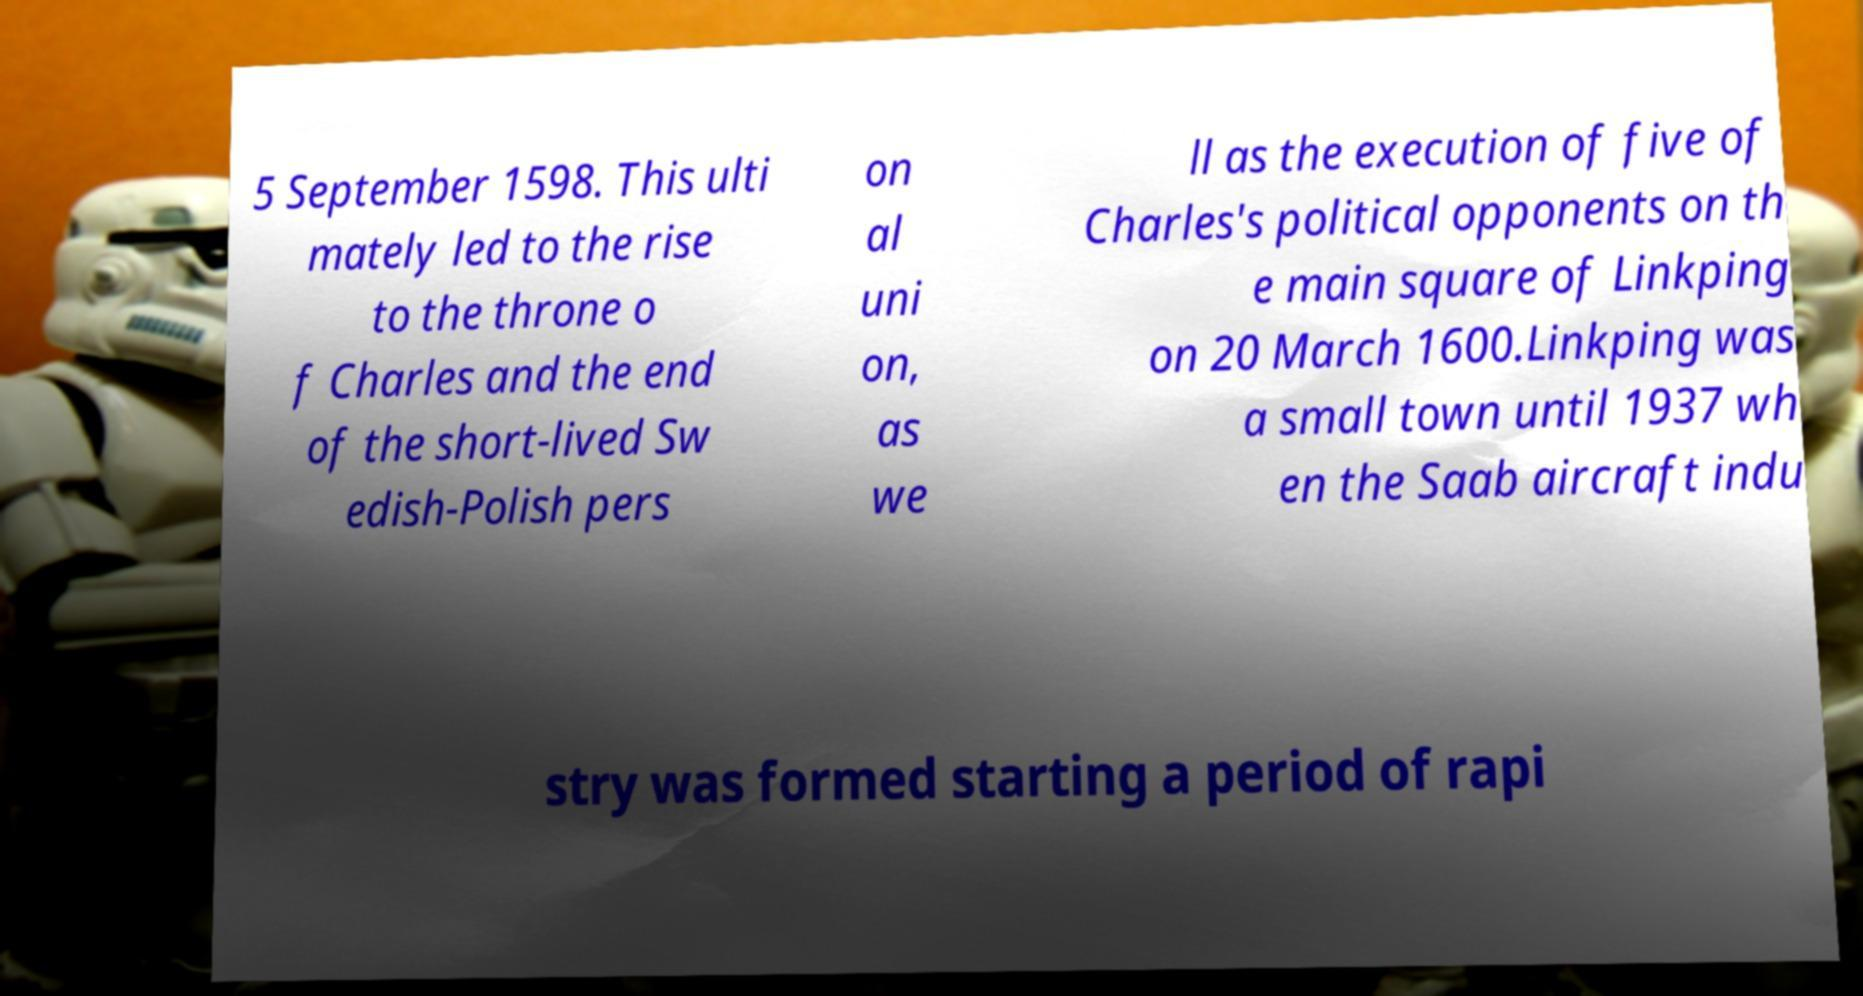Can you read and provide the text displayed in the image?This photo seems to have some interesting text. Can you extract and type it out for me? 5 September 1598. This ulti mately led to the rise to the throne o f Charles and the end of the short-lived Sw edish-Polish pers on al uni on, as we ll as the execution of five of Charles's political opponents on th e main square of Linkping on 20 March 1600.Linkping was a small town until 1937 wh en the Saab aircraft indu stry was formed starting a period of rapi 